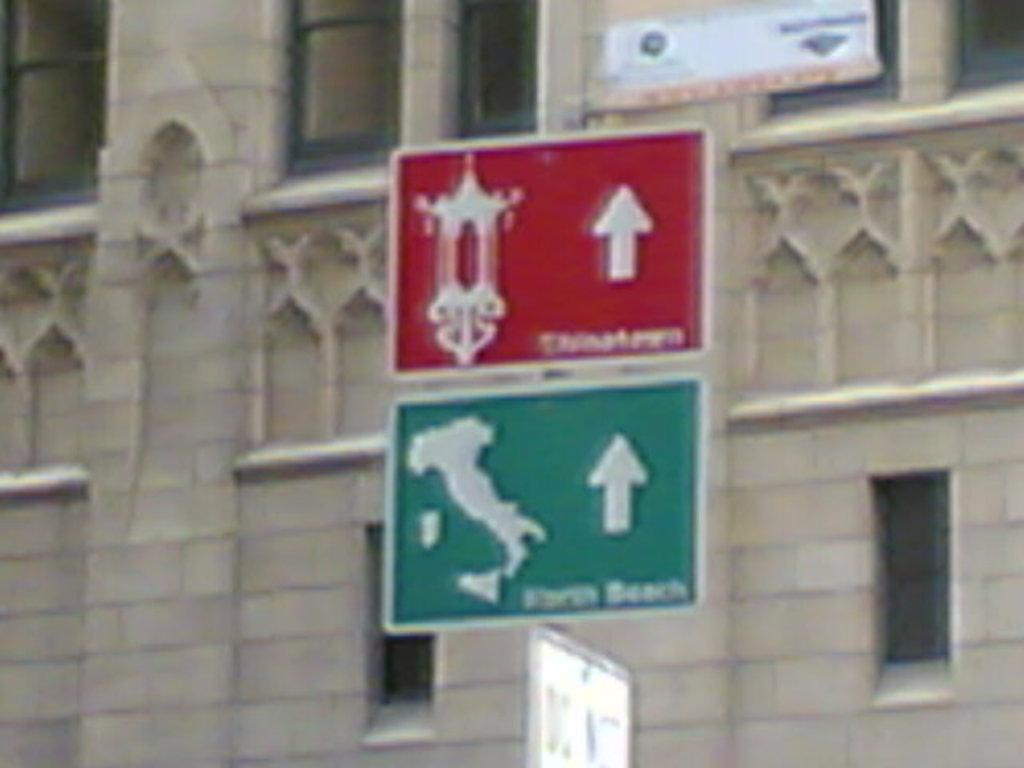What is located in the center of the image? There are sign boards in the center of the image. Can you describe the background of the image? There is a building in the background of the image. How many pins are on the floor in the image? There are no pins visible on the floor in the image. Can you describe the kicking action taking place in the image? There is no kicking action present in the image. 